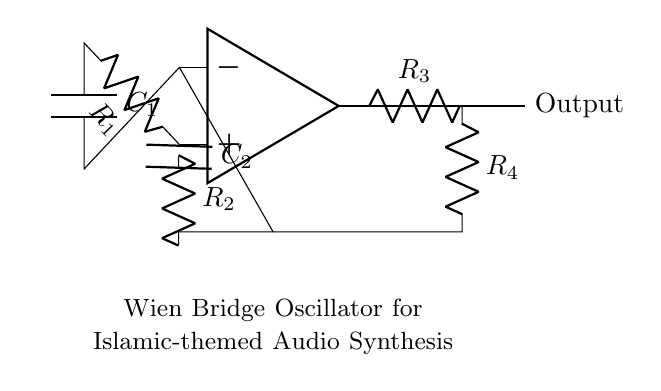What type of oscillator is this? The circuit diagram depicts a Wien Bridge Oscillator, characterized by its use of a Wien network of resistors and capacitors to produce sine waves.
Answer: Wien Bridge Oscillator How many capacitors are in this circuit? There are two capacitors, indicated as C1 and C2 in the circuit diagram. Both are essential for determining the oscillation frequency.
Answer: 2 What is the output of this oscillator? The output signal is typically a sine wave, which can be used for sound synthesis in media. This is derived from the oscillation created by the feedback loop.
Answer: Sine wave Which component is primarily responsible for feedback? The resistors R3 and R4 in combination with the capacitors facilitate the feedback necessary for sustaining the oscillation in the Wien bridge oscillator.
Answer: Resistors What is the role of the op-amp in this circuit? The operational amplifier (op-amp) amplifies the voltage difference between its inputs and is crucial for generating a sustained oscillation in conjunction with the rest of the circuit components.
Answer: Amplification What determines the frequency of oscillation? The frequency of oscillation in a Wien bridge oscillator is determined by the values of R1, R2, C1, and C2 according to the formula f = 1 / (2πRC), where R is the equivalent resistance and C the capacitance.
Answer: R1, R2, C1, C2 